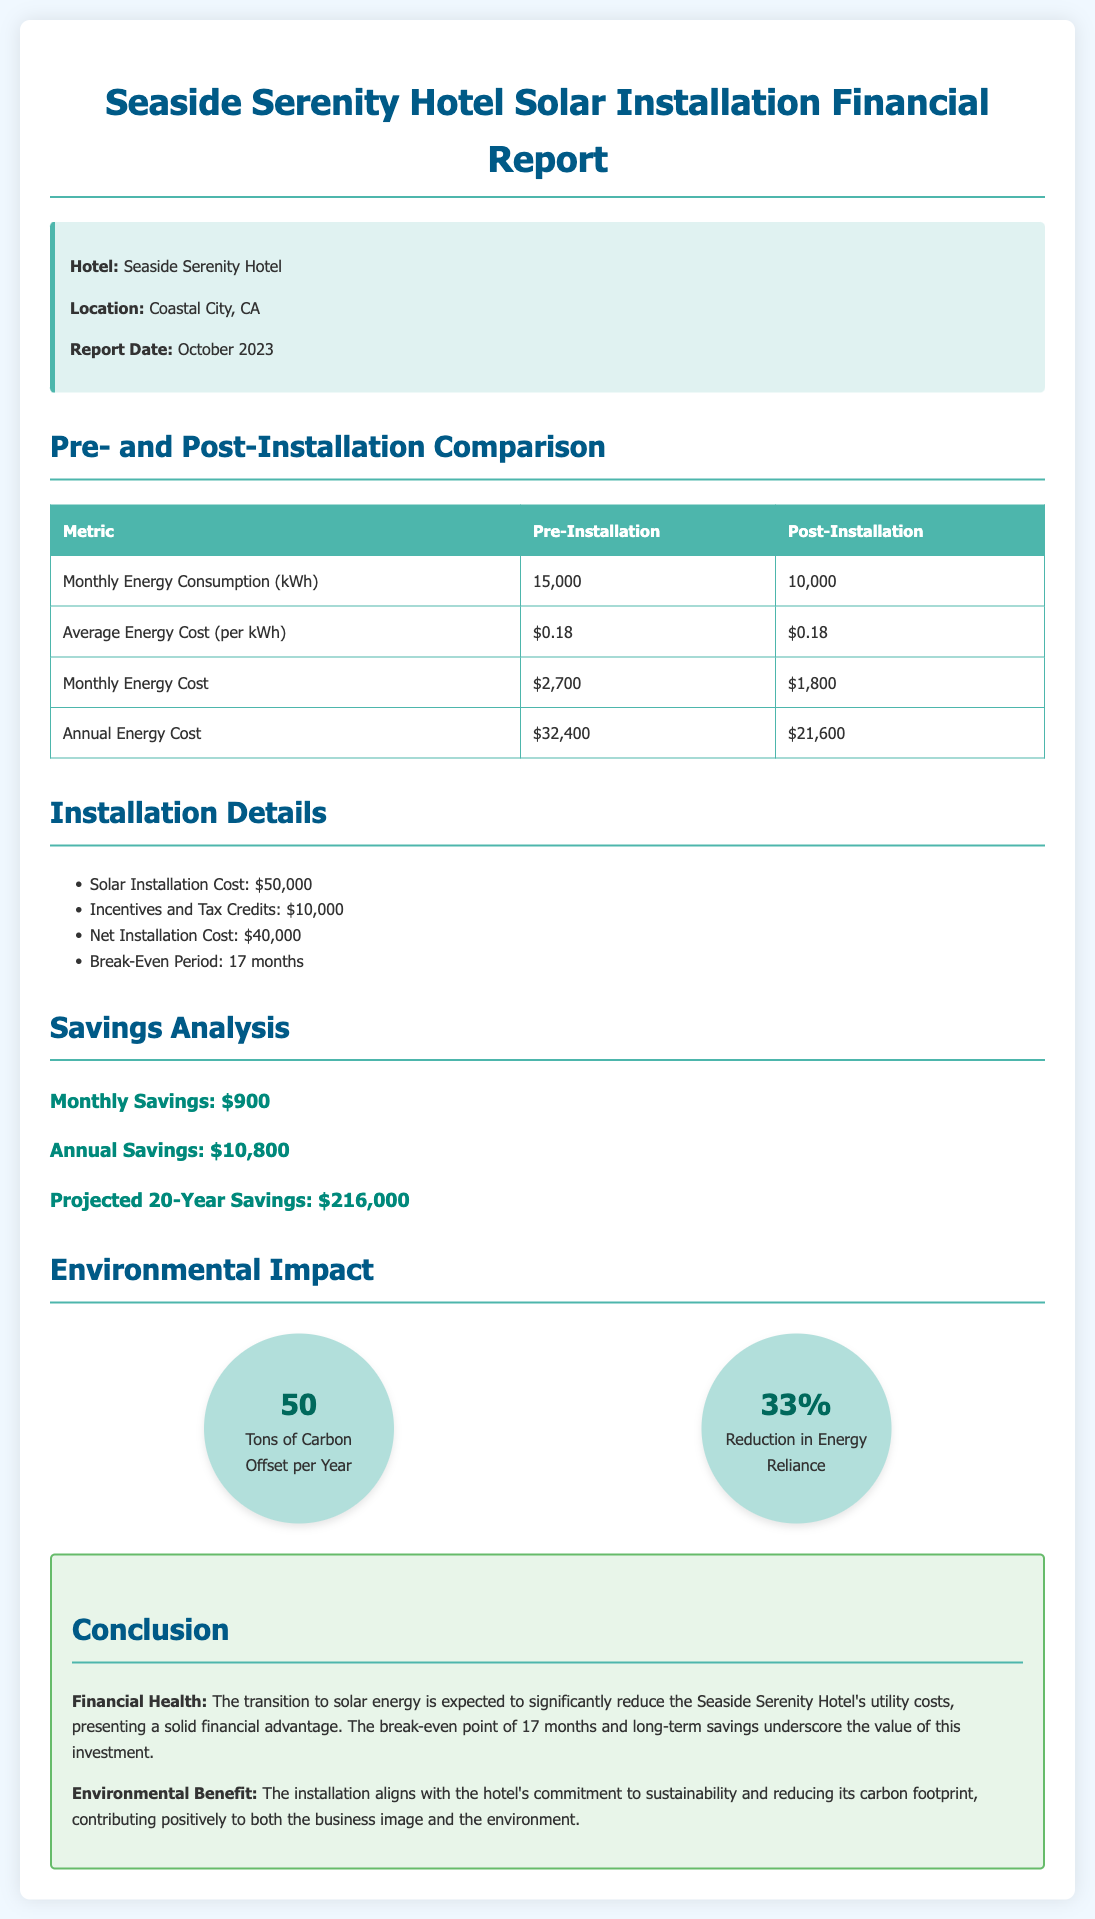What is the hotel's name? The hotel name is mentioned in the report title and the info box.
Answer: Seaside Serenity Hotel What is the average energy cost per kWh? The average energy cost per kWh is presented in the comparison table.
Answer: $0.18 What is the monthly energy consumption post-installation? The post-installation monthly energy consumption is listed in the comparison table.
Answer: 10,000 kWh What was the total installation cost? The total installation cost is specified in the installation details section of the report.
Answer: $50,000 What is the break-even period mentioned in the report? The break-even period is provided in the installation details section, representing the time to recoup the initial investment.
Answer: 17 months How much is the annual savings after the solar installation? The annual savings is highlighted in the savings analysis section of the report.
Answer: $10,800 What is the projected total savings over 20 years? The projected 20-year savings is noted in the savings analysis section.
Answer: $216,000 How many tons of carbon are offset per year? The amount of carbon offset per year is displayed in the environmental impact section.
Answer: 50 What percentage reduction in energy reliance is noted? The reduction in energy reliance is also mentioned in the environmental impact section.
Answer: 33% 